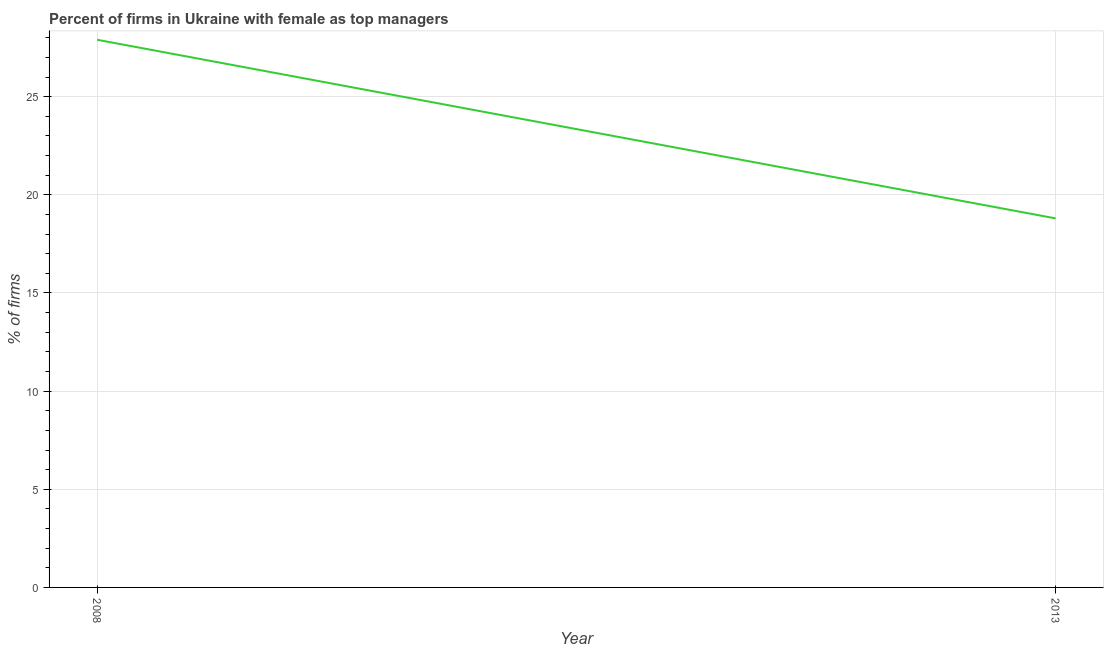What is the percentage of firms with female as top manager in 2008?
Provide a short and direct response. 27.9. Across all years, what is the maximum percentage of firms with female as top manager?
Your answer should be very brief. 27.9. In which year was the percentage of firms with female as top manager maximum?
Ensure brevity in your answer.  2008. In which year was the percentage of firms with female as top manager minimum?
Keep it short and to the point. 2013. What is the sum of the percentage of firms with female as top manager?
Ensure brevity in your answer.  46.7. What is the difference between the percentage of firms with female as top manager in 2008 and 2013?
Provide a succinct answer. 9.1. What is the average percentage of firms with female as top manager per year?
Ensure brevity in your answer.  23.35. What is the median percentage of firms with female as top manager?
Your answer should be very brief. 23.35. What is the ratio of the percentage of firms with female as top manager in 2008 to that in 2013?
Your response must be concise. 1.48. Is the percentage of firms with female as top manager in 2008 less than that in 2013?
Provide a succinct answer. No. In how many years, is the percentage of firms with female as top manager greater than the average percentage of firms with female as top manager taken over all years?
Offer a terse response. 1. How many years are there in the graph?
Keep it short and to the point. 2. Are the values on the major ticks of Y-axis written in scientific E-notation?
Give a very brief answer. No. Does the graph contain grids?
Provide a succinct answer. Yes. What is the title of the graph?
Offer a very short reply. Percent of firms in Ukraine with female as top managers. What is the label or title of the Y-axis?
Provide a short and direct response. % of firms. What is the % of firms of 2008?
Offer a terse response. 27.9. What is the % of firms of 2013?
Offer a terse response. 18.8. What is the ratio of the % of firms in 2008 to that in 2013?
Give a very brief answer. 1.48. 